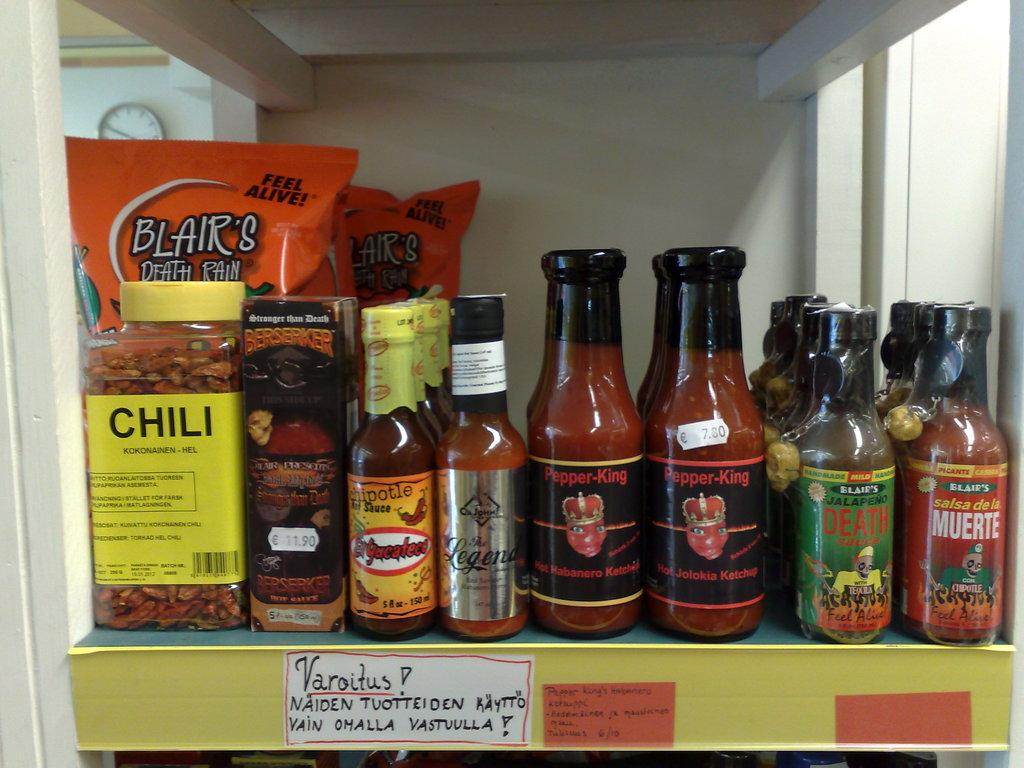<image>
Write a terse but informative summary of the picture. A shelf with various bottle of hot sauce and Chili. 